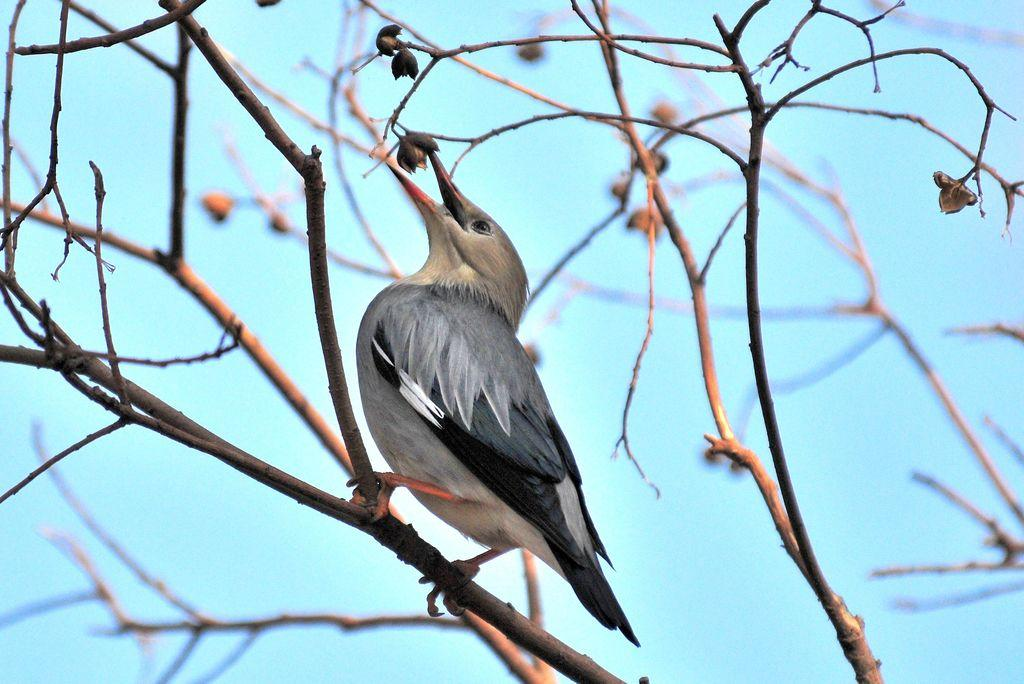What type of animal can be seen in the image? There is a bird in the image. Where is the bird located? The bird is standing on a tree stem. What is the bird doing in the image? The bird is eating cotton seeds. What is the limit of the bird's pocket in the image? There is no mention of a pocket in the image, as birds do not have pockets. 